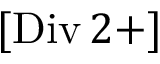Convert formula to latex. <formula><loc_0><loc_0><loc_500><loc_500>[ D i v \, 2 + ]</formula> 